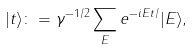Convert formula to latex. <formula><loc_0><loc_0><loc_500><loc_500>| t \rangle \colon = \gamma ^ { - 1 / 2 } \sum _ { E } e ^ { - i E t / } | E \rangle ,</formula> 